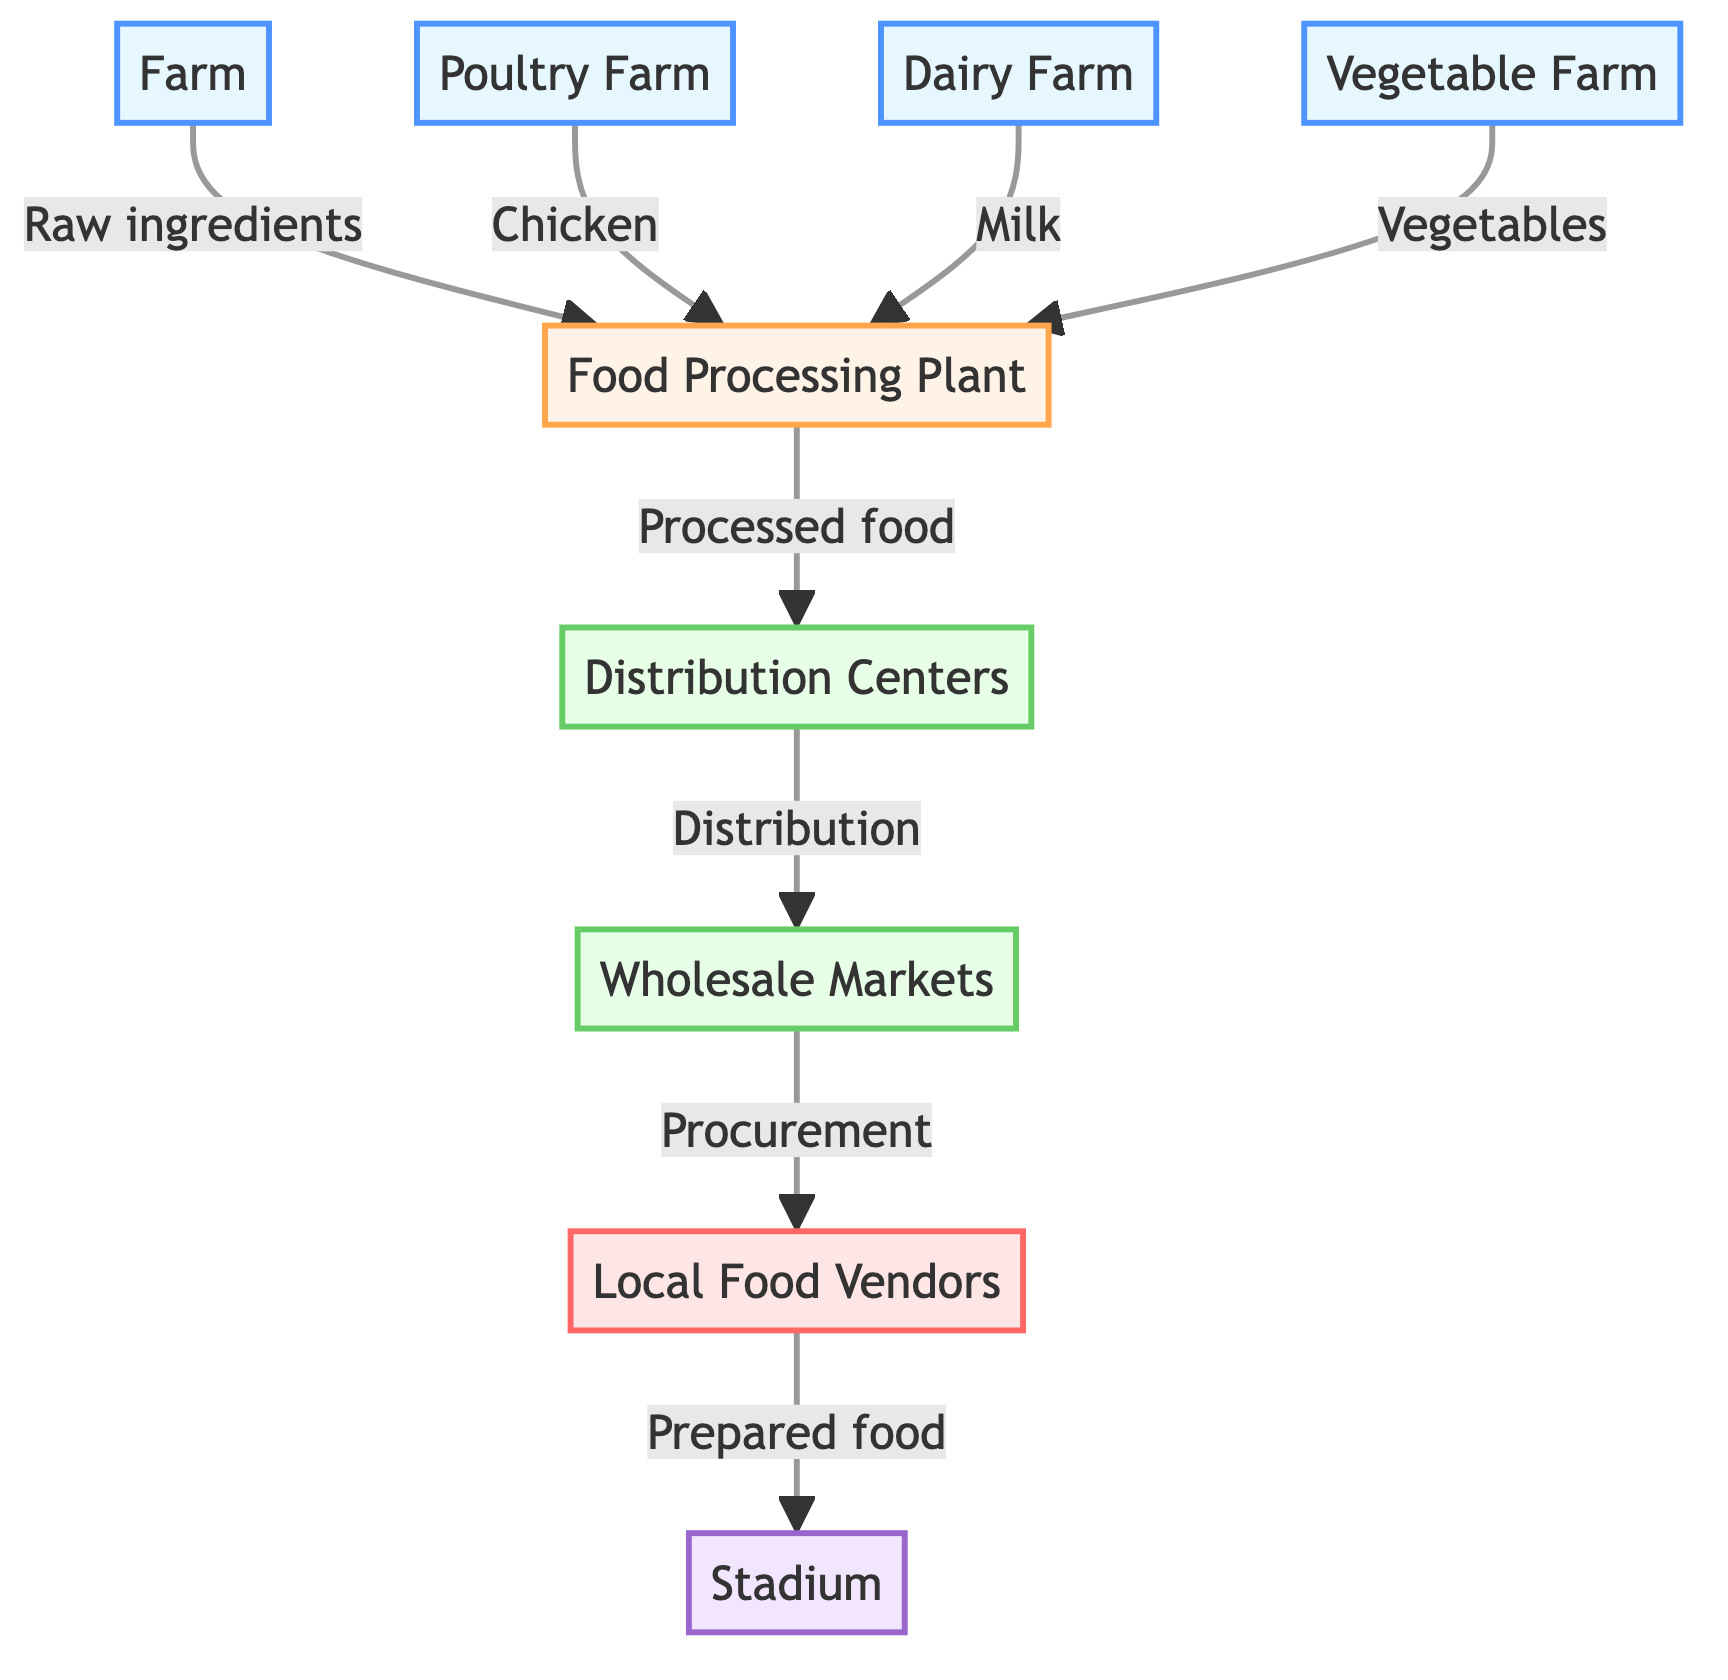What's the total number of nodes in the diagram? The diagram has five farms, one processing plant, two distribution centers, one wholesale market, one local food vendor, and one stadium. Adding these up gives a total of ten nodes.
Answer: 10 Which farm supplies milk? The diagram specifically labels the "Dairy Farm" as the source of milk, indicated by the connection to the food processing plant.
Answer: Dairy Farm What type of food comes from the poultry farm? The diagram clearly indicates that the poultry farm supplies "Chicken" to the food processing plant.
Answer: Chicken How do processed foods reach local food vendors? Processed foods move from the food processing plant to distribution centers, which then distribute to wholesale markets. The local food vendors procure the food from these wholesale markets, tying them directly to the processed food flow.
Answer: Through wholesale markets What is the role of distribution centers in the diagram? Distribution centers serve as a relay point for processed food from the food processing plant to wholesale markets, managing the logistics of the food supply chain before it reaches local vendors.
Answer: Relay point Which farm provides vegetables? The "Vegetable Farm" is the designated provider for vegetables in the diagram, showing a direct connection to the food processing plant.
Answer: Vegetable Farm What indicates the connection between local food vendors and the stadium? The arrow leading from "Local Food Vendors" to "Stadium" represents the flow of "Prepared food", indicating that vendors supply food directly to the stadium for game day.
Answer: Prepared food How many types of farms are shown in the diagram? The diagram illustrates three types of farms: Poultry Farm, Dairy Farm, and Vegetable Farm. Therefore, the total number of farm types is three.
Answer: Three Which stage in the food chain involves processing? The "Food Processing Plant" is the designated stage where raw ingredients from various farms, such as chicken, milk, and vegetables, are transformed into processed food.
Answer: Food Processing Plant 